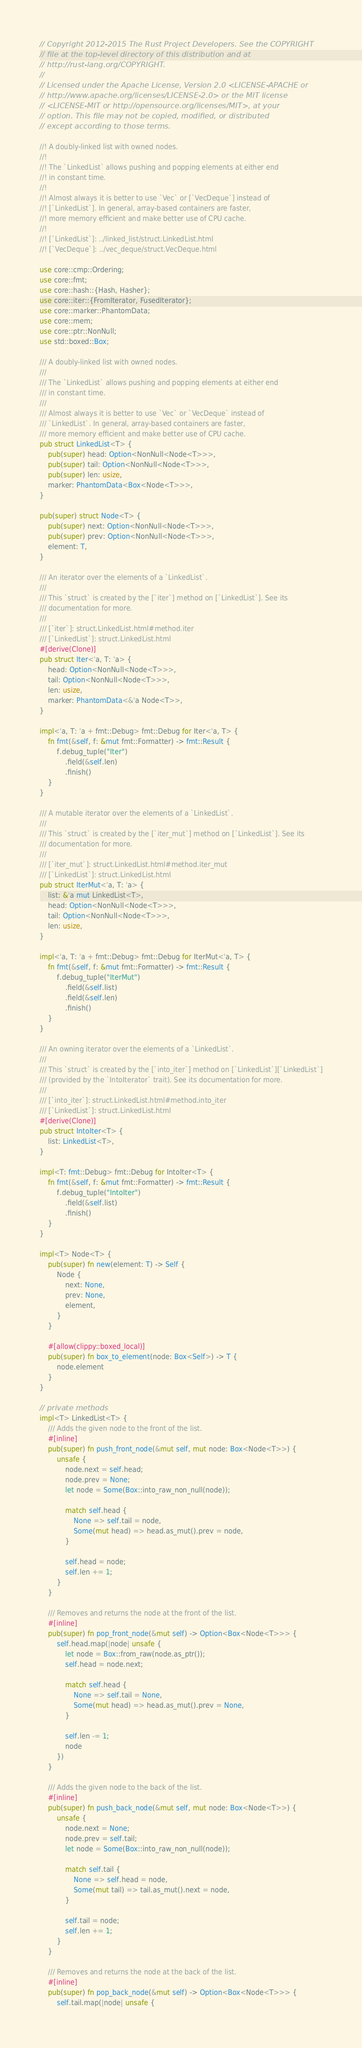Convert code to text. <code><loc_0><loc_0><loc_500><loc_500><_Rust_>// Copyright 2012-2015 The Rust Project Developers. See the COPYRIGHT
// file at the top-level directory of this distribution and at
// http://rust-lang.org/COPYRIGHT.
//
// Licensed under the Apache License, Version 2.0 <LICENSE-APACHE or
// http://www.apache.org/licenses/LICENSE-2.0> or the MIT license
// <LICENSE-MIT or http://opensource.org/licenses/MIT>, at your
// option. This file may not be copied, modified, or distributed
// except according to those terms.

//! A doubly-linked list with owned nodes.
//!
//! The `LinkedList` allows pushing and popping elements at either end
//! in constant time.
//!
//! Almost always it is better to use `Vec` or [`VecDeque`] instead of
//! [`LinkedList`]. In general, array-based containers are faster,
//! more memory efficient and make better use of CPU cache.
//!
//! [`LinkedList`]: ../linked_list/struct.LinkedList.html
//! [`VecDeque`]: ../vec_deque/struct.VecDeque.html

use core::cmp::Ordering;
use core::fmt;
use core::hash::{Hash, Hasher};
use core::iter::{FromIterator, FusedIterator};
use core::marker::PhantomData;
use core::mem;
use core::ptr::NonNull;
use std::boxed::Box;

/// A doubly-linked list with owned nodes.
///
/// The `LinkedList` allows pushing and popping elements at either end
/// in constant time.
///
/// Almost always it is better to use `Vec` or `VecDeque` instead of
/// `LinkedList`. In general, array-based containers are faster,
/// more memory efficient and make better use of CPU cache.
pub struct LinkedList<T> {
    pub(super) head: Option<NonNull<Node<T>>>,
    pub(super) tail: Option<NonNull<Node<T>>>,
    pub(super) len: usize,
    marker: PhantomData<Box<Node<T>>>,
}

pub(super) struct Node<T> {
    pub(super) next: Option<NonNull<Node<T>>>,
    pub(super) prev: Option<NonNull<Node<T>>>,
    element: T,
}

/// An iterator over the elements of a `LinkedList`.
///
/// This `struct` is created by the [`iter`] method on [`LinkedList`]. See its
/// documentation for more.
///
/// [`iter`]: struct.LinkedList.html#method.iter
/// [`LinkedList`]: struct.LinkedList.html
#[derive(Clone)]
pub struct Iter<'a, T: 'a> {
    head: Option<NonNull<Node<T>>>,
    tail: Option<NonNull<Node<T>>>,
    len: usize,
    marker: PhantomData<&'a Node<T>>,
}

impl<'a, T: 'a + fmt::Debug> fmt::Debug for Iter<'a, T> {
    fn fmt(&self, f: &mut fmt::Formatter) -> fmt::Result {
        f.debug_tuple("Iter")
            .field(&self.len)
            .finish()
    }
}

/// A mutable iterator over the elements of a `LinkedList`.
///
/// This `struct` is created by the [`iter_mut`] method on [`LinkedList`]. See its
/// documentation for more.
///
/// [`iter_mut`]: struct.LinkedList.html#method.iter_mut
/// [`LinkedList`]: struct.LinkedList.html
pub struct IterMut<'a, T: 'a> {
    list: &'a mut LinkedList<T>,
    head: Option<NonNull<Node<T>>>,
    tail: Option<NonNull<Node<T>>>,
    len: usize,
}

impl<'a, T: 'a + fmt::Debug> fmt::Debug for IterMut<'a, T> {
    fn fmt(&self, f: &mut fmt::Formatter) -> fmt::Result {
        f.debug_tuple("IterMut")
            .field(&self.list)
            .field(&self.len)
            .finish()
    }
}

/// An owning iterator over the elements of a `LinkedList`.
///
/// This `struct` is created by the [`into_iter`] method on [`LinkedList`][`LinkedList`]
/// (provided by the `IntoIterator` trait). See its documentation for more.
///
/// [`into_iter`]: struct.LinkedList.html#method.into_iter
/// [`LinkedList`]: struct.LinkedList.html
#[derive(Clone)]
pub struct IntoIter<T> {
    list: LinkedList<T>,
}

impl<T: fmt::Debug> fmt::Debug for IntoIter<T> {
    fn fmt(&self, f: &mut fmt::Formatter) -> fmt::Result {
        f.debug_tuple("IntoIter")
            .field(&self.list)
            .finish()
    }
}

impl<T> Node<T> {
    pub(super) fn new(element: T) -> Self {
        Node {
            next: None,
            prev: None,
            element,
        }
    }

    #[allow(clippy::boxed_local)]
    pub(super) fn box_to_element(node: Box<Self>) -> T {
        node.element
    }
}

// private methods
impl<T> LinkedList<T> {
    /// Adds the given node to the front of the list.
    #[inline]
    pub(super) fn push_front_node(&mut self, mut node: Box<Node<T>>) {
        unsafe {
            node.next = self.head;
            node.prev = None;
            let node = Some(Box::into_raw_non_null(node));

            match self.head {
                None => self.tail = node,
                Some(mut head) => head.as_mut().prev = node,
            }

            self.head = node;
            self.len += 1;
        }
    }

    /// Removes and returns the node at the front of the list.
    #[inline]
    pub(super) fn pop_front_node(&mut self) -> Option<Box<Node<T>>> {
        self.head.map(|node| unsafe {
            let node = Box::from_raw(node.as_ptr());
            self.head = node.next;

            match self.head {
                None => self.tail = None,
                Some(mut head) => head.as_mut().prev = None,
            }

            self.len -= 1;
            node
        })
    }

    /// Adds the given node to the back of the list.
    #[inline]
    pub(super) fn push_back_node(&mut self, mut node: Box<Node<T>>) {
        unsafe {
            node.next = None;
            node.prev = self.tail;
            let node = Some(Box::into_raw_non_null(node));

            match self.tail {
                None => self.head = node,
                Some(mut tail) => tail.as_mut().next = node,
            }

            self.tail = node;
            self.len += 1;
        }
    }

    /// Removes and returns the node at the back of the list.
    #[inline]
    pub(super) fn pop_back_node(&mut self) -> Option<Box<Node<T>>> {
        self.tail.map(|node| unsafe {</code> 